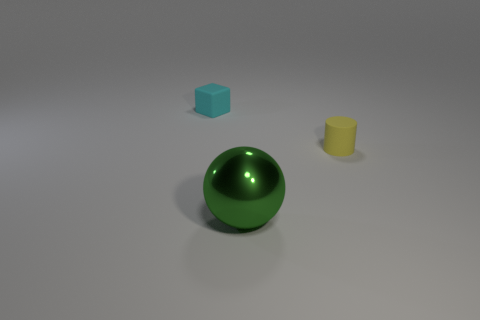Is there anything else that has the same material as the ball?
Your response must be concise. No. The rubber object that is the same size as the cyan rubber block is what color?
Make the answer very short. Yellow. There is a yellow thing; does it have the same shape as the small thing on the left side of the sphere?
Your response must be concise. No. There is a small thing that is on the right side of the rubber thing on the left side of the object to the right of the big shiny sphere; what is it made of?
Keep it short and to the point. Rubber. What number of tiny things are either brown metallic cylinders or spheres?
Keep it short and to the point. 0. How many other objects are the same size as the matte cube?
Give a very brief answer. 1. Does the object that is in front of the tiny matte cylinder have the same shape as the cyan matte thing?
Provide a short and direct response. No. Is there anything else that has the same shape as the cyan object?
Your answer should be compact. No. Are there an equal number of large green things that are on the right side of the big green shiny sphere and yellow metal cubes?
Your response must be concise. Yes. How many objects are both to the right of the cyan rubber cube and behind the large green thing?
Offer a terse response. 1. 